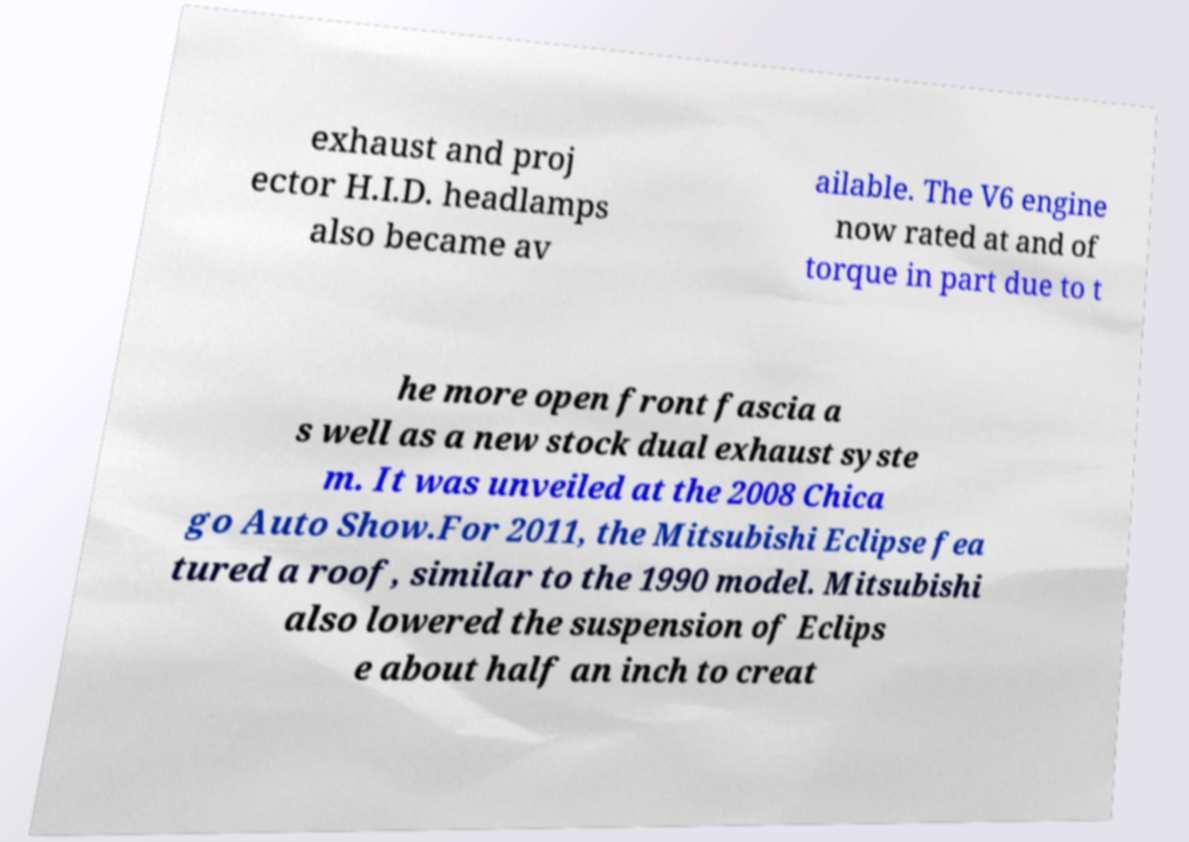I need the written content from this picture converted into text. Can you do that? exhaust and proj ector H.I.D. headlamps also became av ailable. The V6 engine now rated at and of torque in part due to t he more open front fascia a s well as a new stock dual exhaust syste m. It was unveiled at the 2008 Chica go Auto Show.For 2011, the Mitsubishi Eclipse fea tured a roof, similar to the 1990 model. Mitsubishi also lowered the suspension of Eclips e about half an inch to creat 